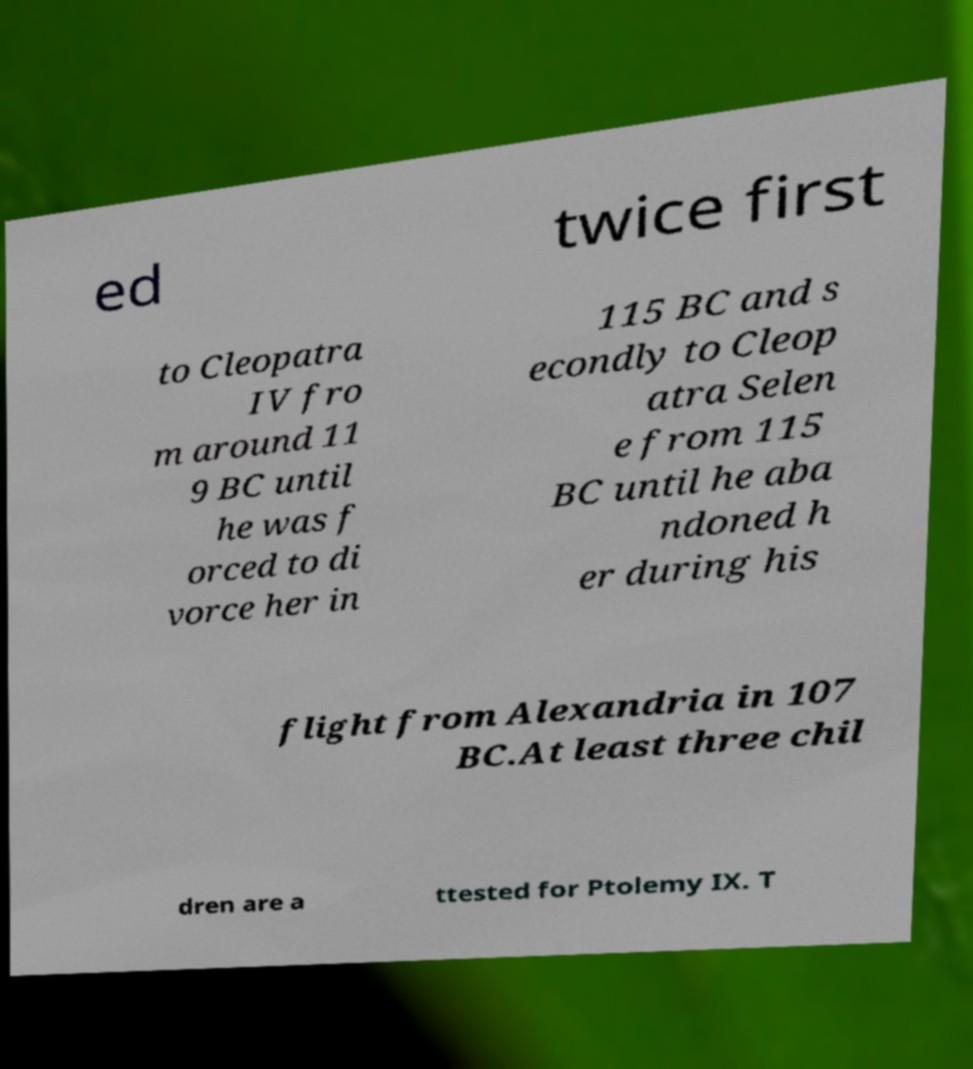Can you read and provide the text displayed in the image?This photo seems to have some interesting text. Can you extract and type it out for me? ed twice first to Cleopatra IV fro m around 11 9 BC until he was f orced to di vorce her in 115 BC and s econdly to Cleop atra Selen e from 115 BC until he aba ndoned h er during his flight from Alexandria in 107 BC.At least three chil dren are a ttested for Ptolemy IX. T 